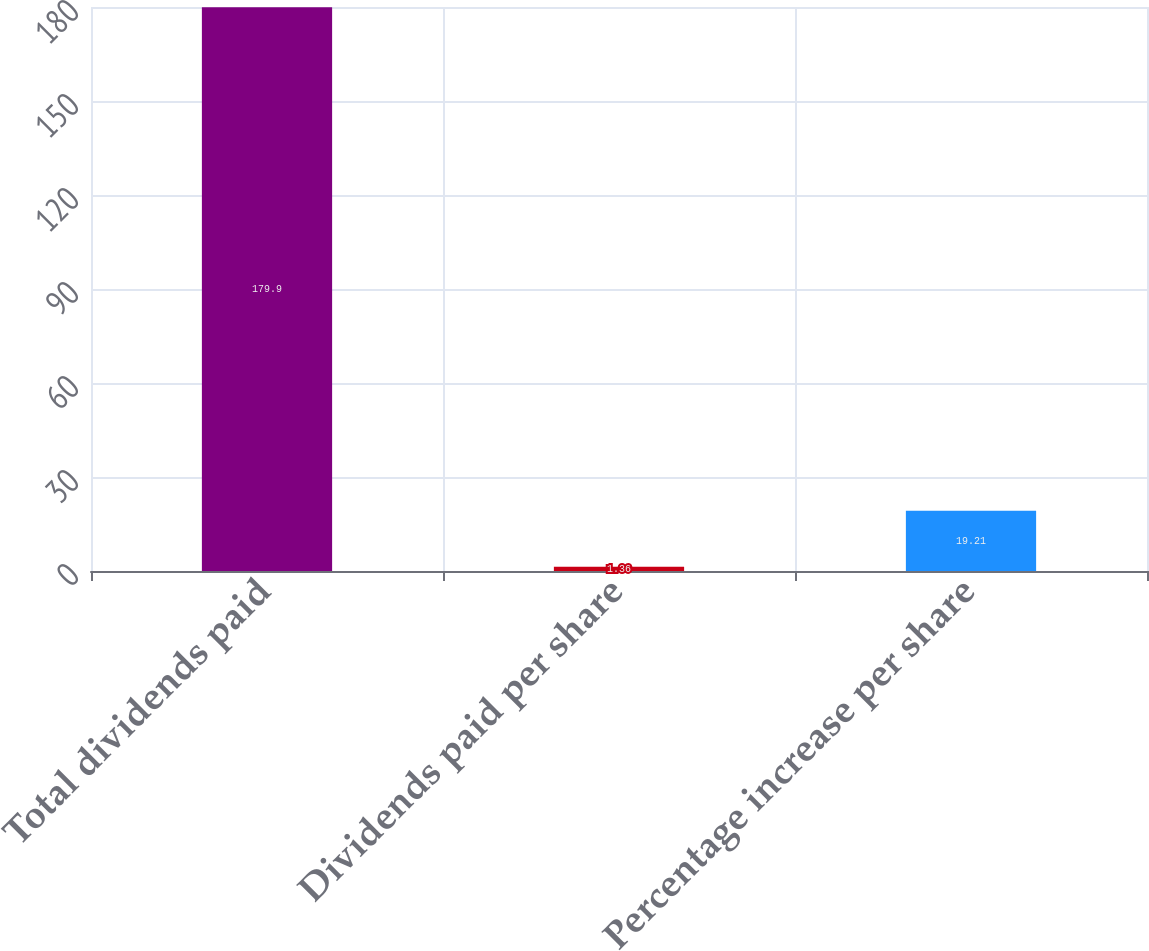Convert chart. <chart><loc_0><loc_0><loc_500><loc_500><bar_chart><fcel>Total dividends paid<fcel>Dividends paid per share<fcel>Percentage increase per share<nl><fcel>179.9<fcel>1.36<fcel>19.21<nl></chart> 